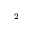<formula> <loc_0><loc_0><loc_500><loc_500>^ { 2 }</formula> 